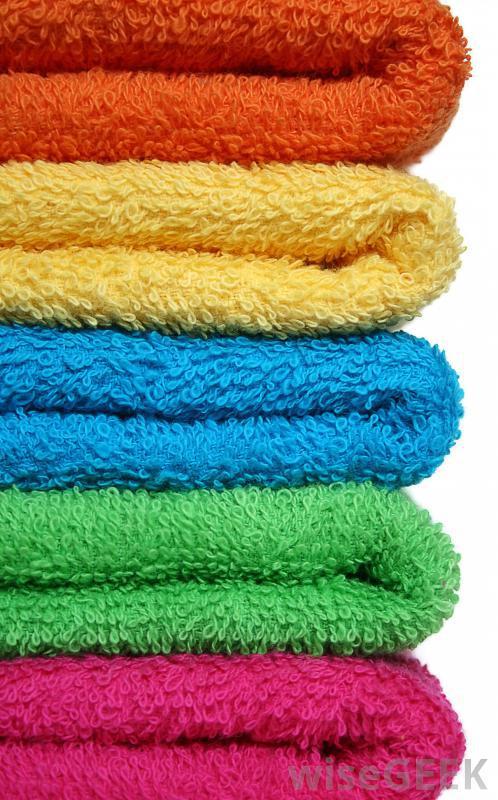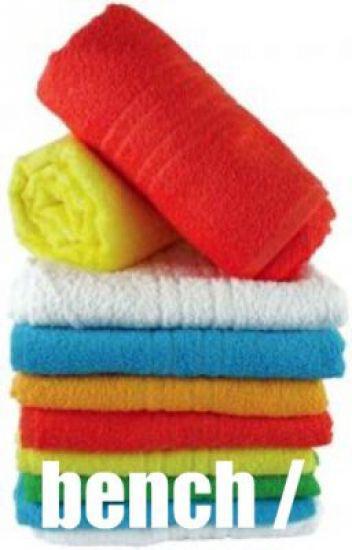The first image is the image on the left, the second image is the image on the right. Considering the images on both sides, is "There are exactly five towels in the left image." valid? Answer yes or no. Yes. 